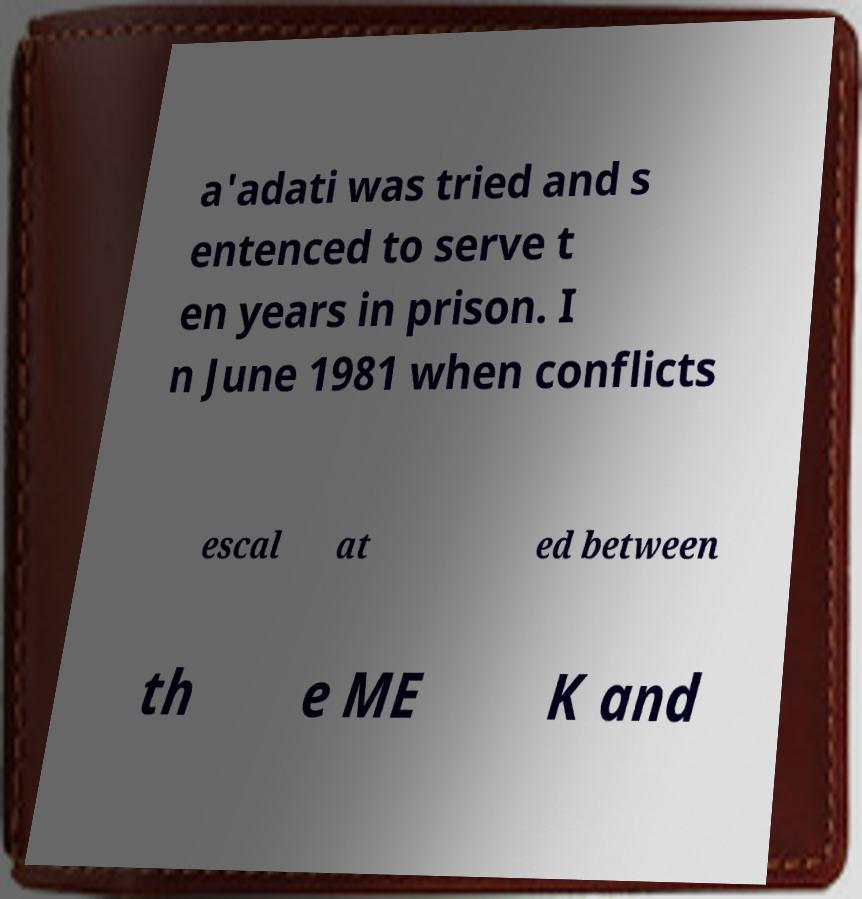Could you extract and type out the text from this image? a'adati was tried and s entenced to serve t en years in prison. I n June 1981 when conflicts escal at ed between th e ME K and 